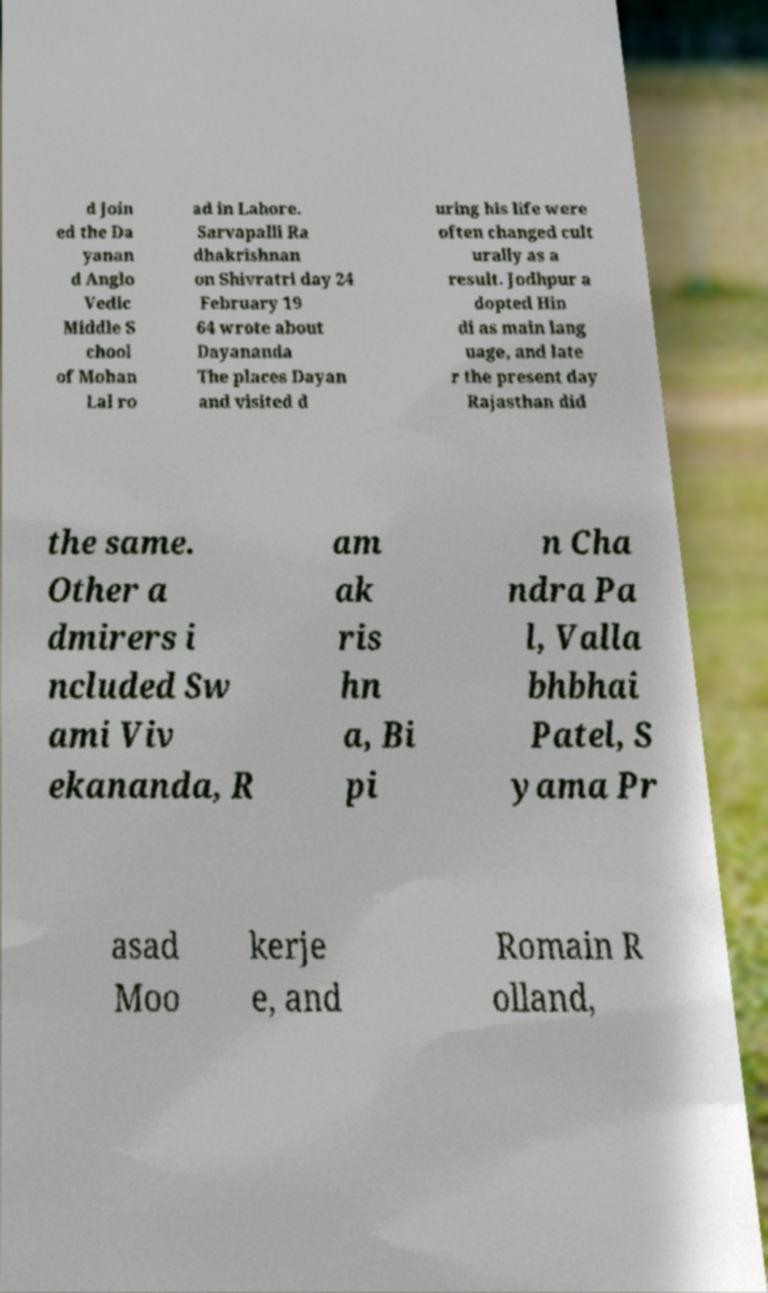Can you read and provide the text displayed in the image?This photo seems to have some interesting text. Can you extract and type it out for me? d join ed the Da yanan d Anglo Vedic Middle S chool of Mohan Lal ro ad in Lahore. Sarvapalli Ra dhakrishnan on Shivratri day 24 February 19 64 wrote about Dayananda The places Dayan and visited d uring his life were often changed cult urally as a result. Jodhpur a dopted Hin di as main lang uage, and late r the present day Rajasthan did the same. Other a dmirers i ncluded Sw ami Viv ekananda, R am ak ris hn a, Bi pi n Cha ndra Pa l, Valla bhbhai Patel, S yama Pr asad Moo kerje e, and Romain R olland, 